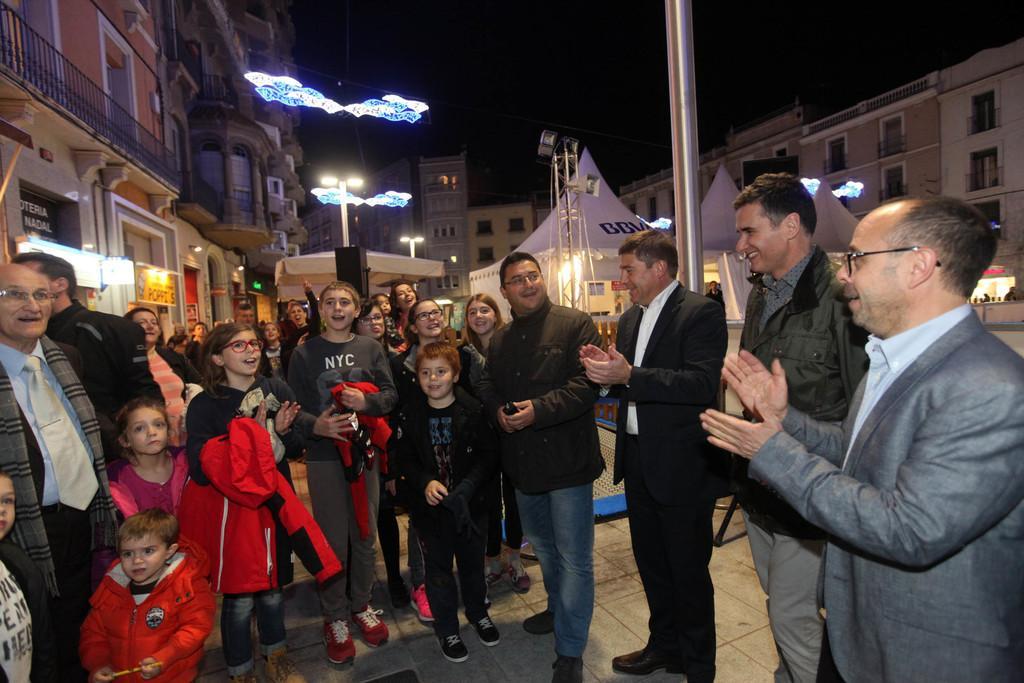How would you summarize this image in a sentence or two? In this image I can see group of people standing. In front the person is holding a red color jacket, background I can see few tents in white color, buildings in brown, cream and white color and I can also see few light poles. 